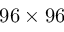<formula> <loc_0><loc_0><loc_500><loc_500>9 6 \times 9 6</formula> 